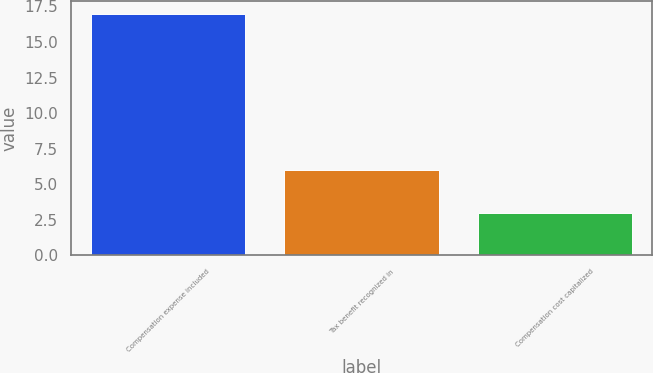Convert chart to OTSL. <chart><loc_0><loc_0><loc_500><loc_500><bar_chart><fcel>Compensation expense included<fcel>Tax benefit recognized in<fcel>Compensation cost capitalized<nl><fcel>17<fcel>6<fcel>3<nl></chart> 